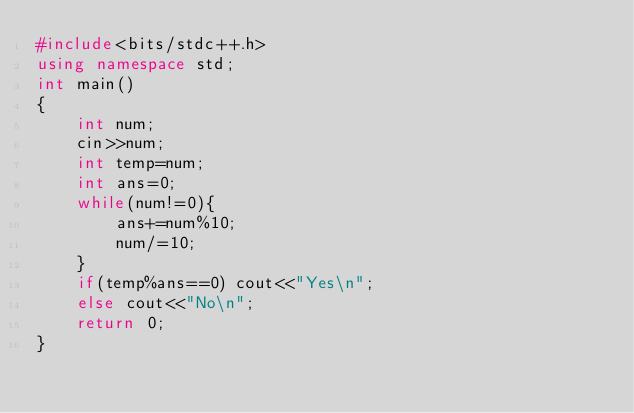<code> <loc_0><loc_0><loc_500><loc_500><_C++_>#include<bits/stdc++.h>
using namespace std;
int main()
{
    int num;
    cin>>num;
    int temp=num;
    int ans=0;
    while(num!=0){
        ans+=num%10;
        num/=10;
    }
    if(temp%ans==0) cout<<"Yes\n";
    else cout<<"No\n";
    return 0;
}
</code> 